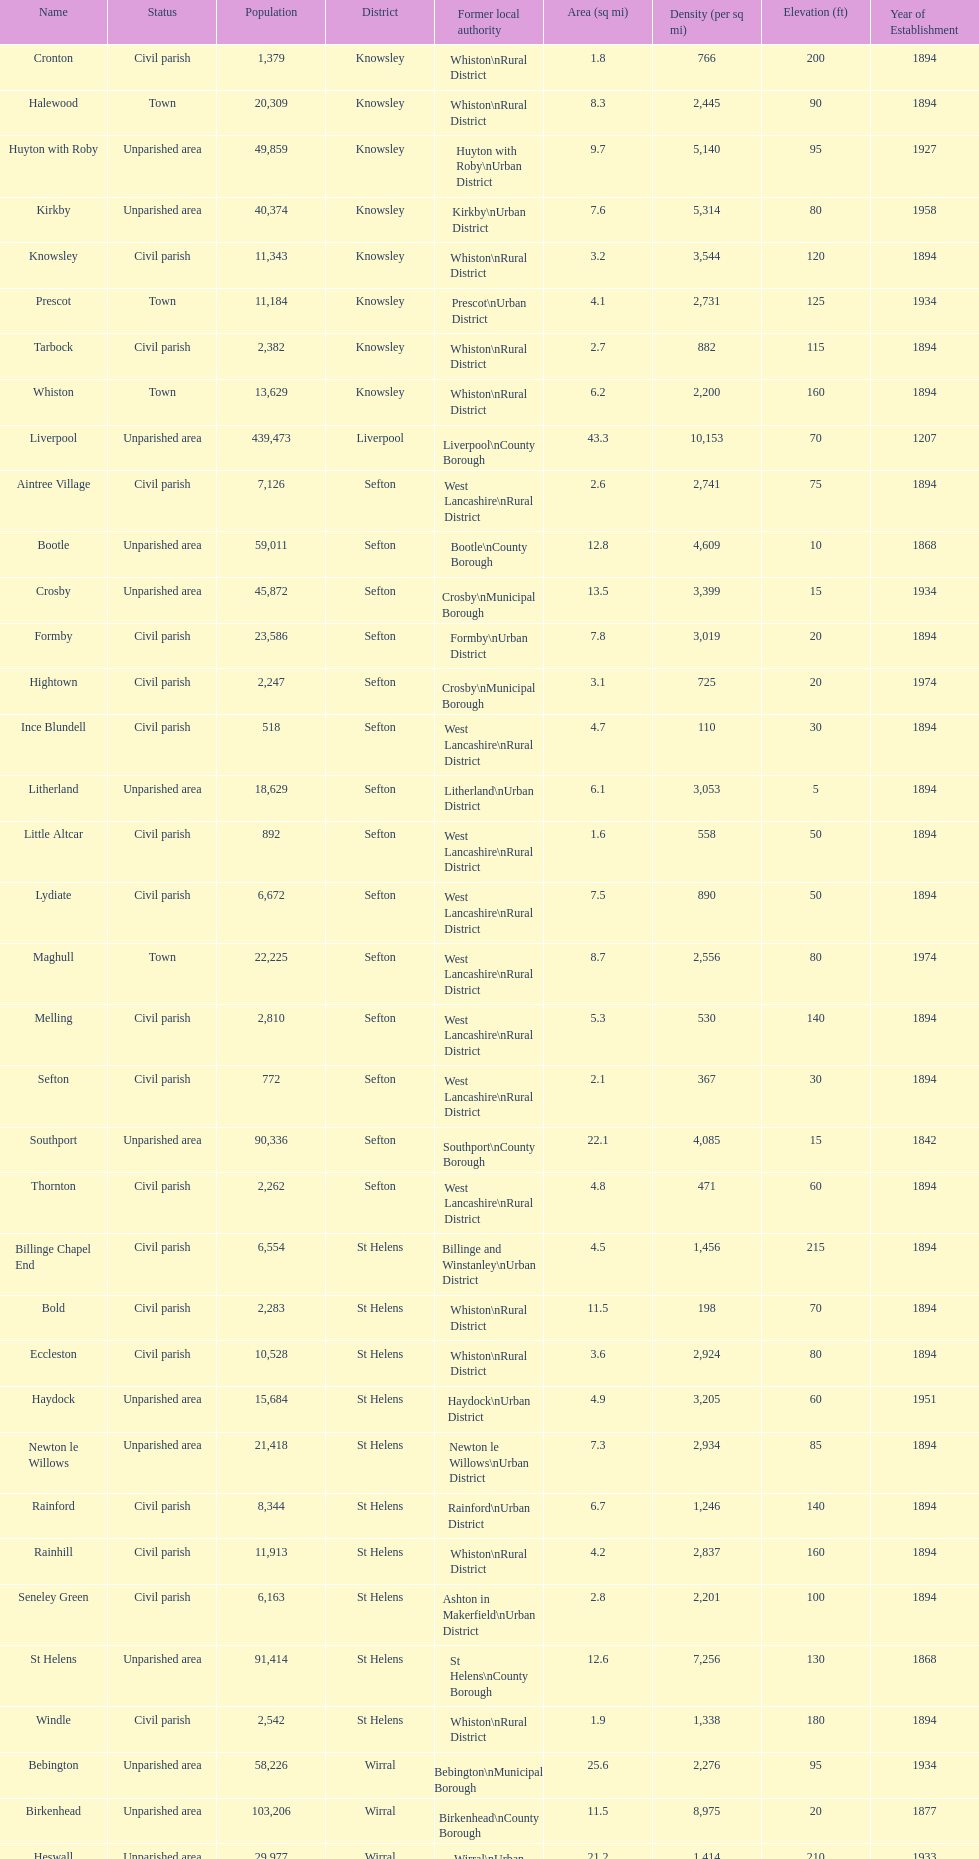Tell me the number of residents in formby. 23,586. Parse the table in full. {'header': ['Name', 'Status', 'Population', 'District', 'Former local authority', 'Area (sq mi)', 'Density (per sq mi)', 'Elevation (ft)', 'Year of Establishment'], 'rows': [['Cronton', 'Civil parish', '1,379', 'Knowsley', 'Whiston\\nRural District', '1.8', '766', '200', '1894'], ['Halewood', 'Town', '20,309', 'Knowsley', 'Whiston\\nRural District', '8.3', '2,445', '90', '1894'], ['Huyton with Roby', 'Unparished area', '49,859', 'Knowsley', 'Huyton with Roby\\nUrban District', '9.7', '5,140', '95', '1927'], ['Kirkby', 'Unparished area', '40,374', 'Knowsley', 'Kirkby\\nUrban District', '7.6', '5,314', '80', '1958'], ['Knowsley', 'Civil parish', '11,343', 'Knowsley', 'Whiston\\nRural District', '3.2', '3,544', '120', '1894'], ['Prescot', 'Town', '11,184', 'Knowsley', 'Prescot\\nUrban District', '4.1', '2,731', '125', '1934'], ['Tarbock', 'Civil parish', '2,382', 'Knowsley', 'Whiston\\nRural District', '2.7', '882', '115', '1894'], ['Whiston', 'Town', '13,629', 'Knowsley', 'Whiston\\nRural District', '6.2', '2,200', '160', '1894'], ['Liverpool', 'Unparished area', '439,473', 'Liverpool', 'Liverpool\\nCounty Borough', '43.3', '10,153', '70', '1207'], ['Aintree Village', 'Civil parish', '7,126', 'Sefton', 'West Lancashire\\nRural District', '2.6', '2,741', '75', '1894'], ['Bootle', 'Unparished area', '59,011', 'Sefton', 'Bootle\\nCounty Borough', '12.8', '4,609', '10', '1868'], ['Crosby', 'Unparished area', '45,872', 'Sefton', 'Crosby\\nMunicipal Borough', '13.5', '3,399', '15', '1934'], ['Formby', 'Civil parish', '23,586', 'Sefton', 'Formby\\nUrban District', '7.8', '3,019', '20', '1894'], ['Hightown', 'Civil parish', '2,247', 'Sefton', 'Crosby\\nMunicipal Borough', '3.1', '725', '20', '1974'], ['Ince Blundell', 'Civil parish', '518', 'Sefton', 'West Lancashire\\nRural District', '4.7', '110', '30', '1894'], ['Litherland', 'Unparished area', '18,629', 'Sefton', 'Litherland\\nUrban District', '6.1', '3,053', '5', '1894'], ['Little Altcar', 'Civil parish', '892', 'Sefton', 'West Lancashire\\nRural District', '1.6', '558', '50', '1894'], ['Lydiate', 'Civil parish', '6,672', 'Sefton', 'West Lancashire\\nRural District', '7.5', '890', '50', '1894'], ['Maghull', 'Town', '22,225', 'Sefton', 'West Lancashire\\nRural District', '8.7', '2,556', '80', '1974'], ['Melling', 'Civil parish', '2,810', 'Sefton', 'West Lancashire\\nRural District', '5.3', '530', '140', '1894'], ['Sefton', 'Civil parish', '772', 'Sefton', 'West Lancashire\\nRural District', '2.1', '367', '30', '1894'], ['Southport', 'Unparished area', '90,336', 'Sefton', 'Southport\\nCounty Borough', '22.1', '4,085', '15', '1842'], ['Thornton', 'Civil parish', '2,262', 'Sefton', 'West Lancashire\\nRural District', '4.8', '471', '60', '1894'], ['Billinge Chapel End', 'Civil parish', '6,554', 'St Helens', 'Billinge and Winstanley\\nUrban District', '4.5', '1,456', '215', '1894'], ['Bold', 'Civil parish', '2,283', 'St Helens', 'Whiston\\nRural District', '11.5', '198', '70', '1894'], ['Eccleston', 'Civil parish', '10,528', 'St Helens', 'Whiston\\nRural District', '3.6', '2,924', '80', '1894'], ['Haydock', 'Unparished area', '15,684', 'St Helens', 'Haydock\\nUrban District', '4.9', '3,205', '60', '1951'], ['Newton le Willows', 'Unparished area', '21,418', 'St Helens', 'Newton le Willows\\nUrban District', '7.3', '2,934', '85', '1894'], ['Rainford', 'Civil parish', '8,344', 'St Helens', 'Rainford\\nUrban District', '6.7', '1,246', '140', '1894'], ['Rainhill', 'Civil parish', '11,913', 'St Helens', 'Whiston\\nRural District', '4.2', '2,837', '160', '1894'], ['Seneley Green', 'Civil parish', '6,163', 'St Helens', 'Ashton in Makerfield\\nUrban District', '2.8', '2,201', '100', '1894'], ['St Helens', 'Unparished area', '91,414', 'St Helens', 'St Helens\\nCounty Borough', '12.6', '7,256', '130', '1868'], ['Windle', 'Civil parish', '2,542', 'St Helens', 'Whiston\\nRural District', '1.9', '1,338', '180', '1894'], ['Bebington', 'Unparished area', '58,226', 'Wirral', 'Bebington\\nMunicipal Borough', '25.6', '2,276', '95', '1934'], ['Birkenhead', 'Unparished area', '103,206', 'Wirral', 'Birkenhead\\nCounty Borough', '11.5', '8,975', '20', '1877'], ['Heswall', 'Unparished area', '29,977', 'Wirral', 'Wirral\\nUrban District', '21.2', '1,414', '210', '1933'], ['Hoylake', 'Unparished area', '35,655', 'Wirral', 'Hoylake\\nUrban District', '17.9', '1,993', '30', '1894'], ['Wallasey', 'Unparished area', '84,348', 'Wirral', 'Wallasey\\nCounty Borough', '19.1', '4,418', '35', '1913']]} 